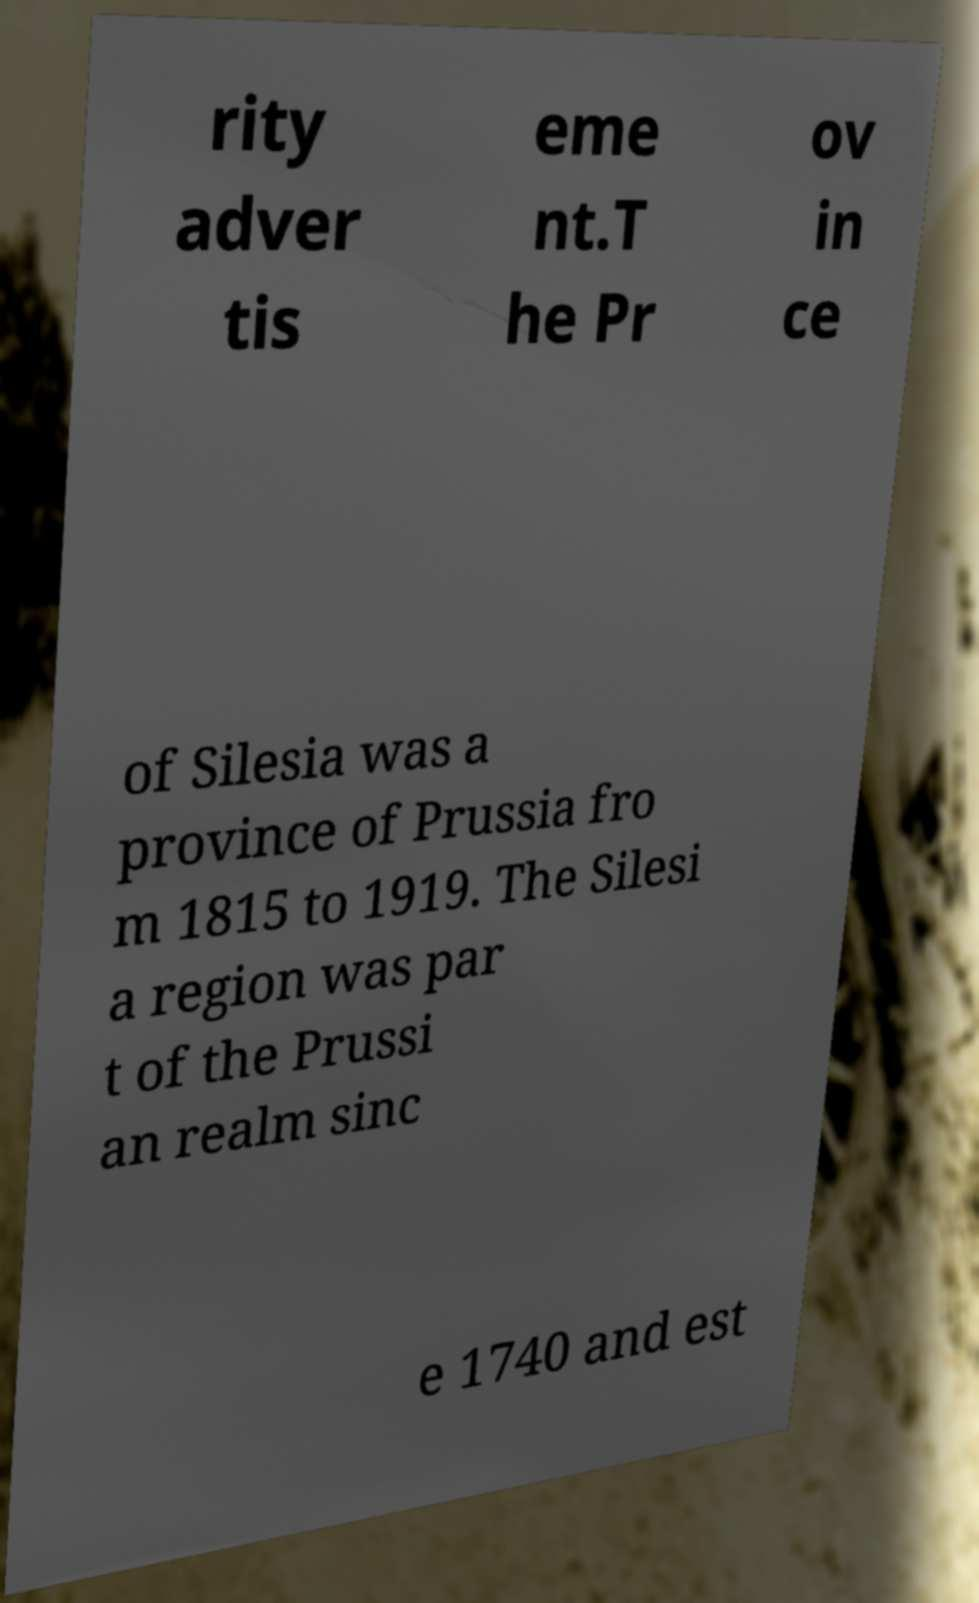Please identify and transcribe the text found in this image. rity adver tis eme nt.T he Pr ov in ce of Silesia was a province of Prussia fro m 1815 to 1919. The Silesi a region was par t of the Prussi an realm sinc e 1740 and est 